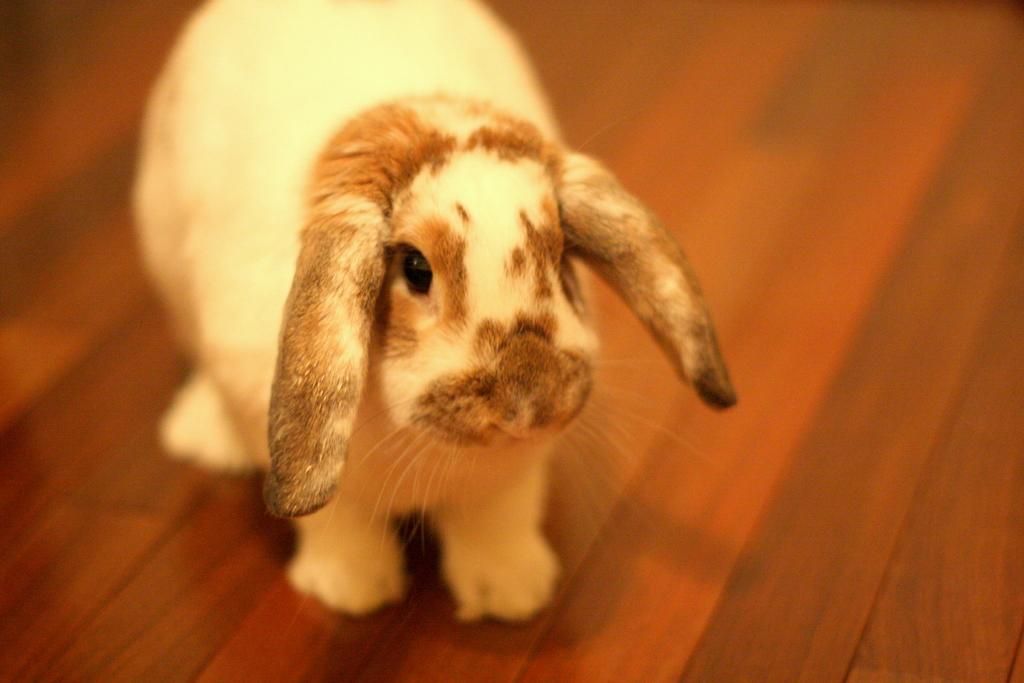What animal is present in the image? There is a rabbit in the image. Can you describe the color of the rabbit? The rabbit is white and brown in color. What is the color of the floor in the image? The floor in the image is brown. Can you see any waves in the image? There are no waves present in the image; it features a rabbit on a brown floor. 